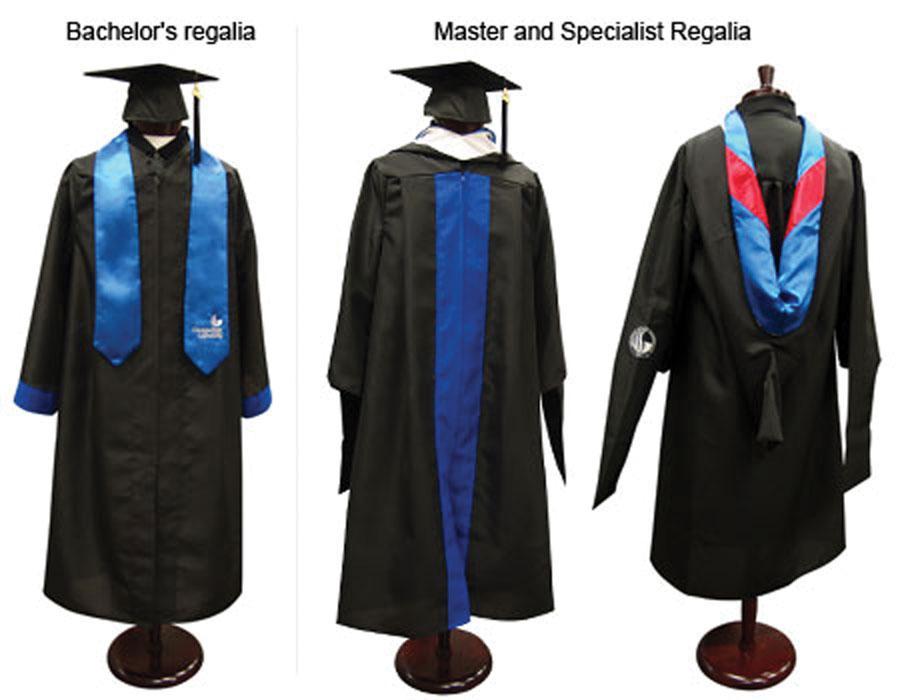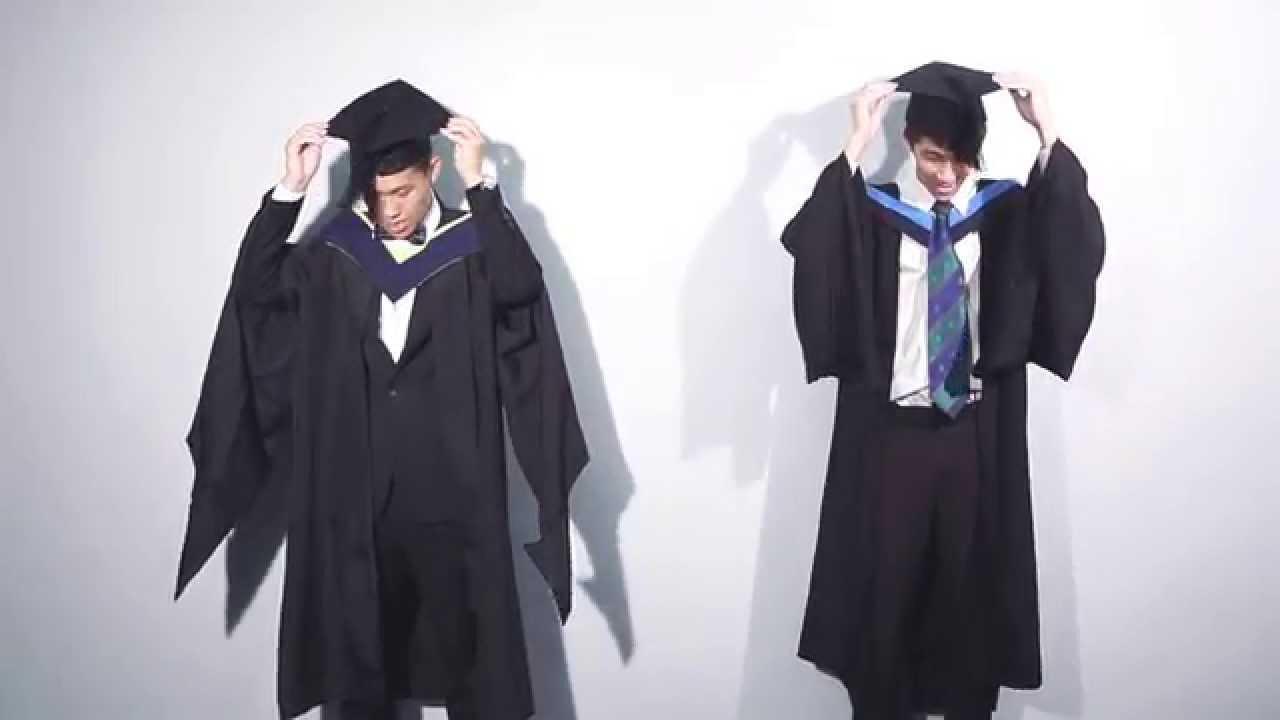The first image is the image on the left, the second image is the image on the right. For the images shown, is this caption "There are at most 4 graduation gowns in the image pair" true? Answer yes or no. No. The first image is the image on the left, the second image is the image on the right. For the images displayed, is the sentence "In the left image, you will find no people." factually correct? Answer yes or no. Yes. 